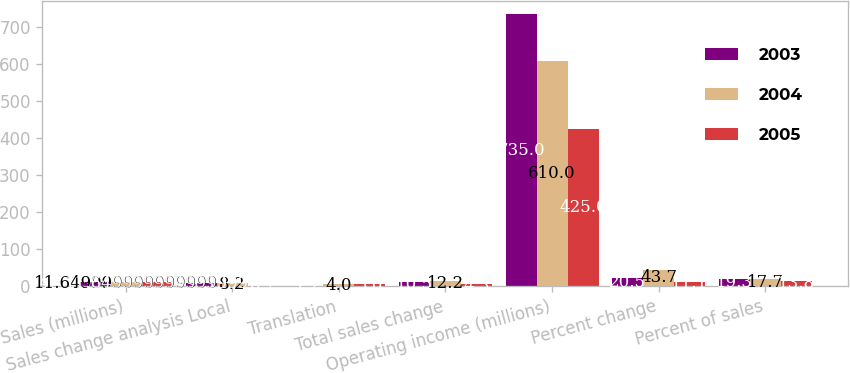Convert chart. <chart><loc_0><loc_0><loc_500><loc_500><stacked_bar_chart><ecel><fcel>Sales (millions)<fcel>Sales change analysis Local<fcel>Translation<fcel>Total sales change<fcel>Operating income (millions)<fcel>Percent change<fcel>Percent of sales<nl><fcel>2003<fcel>11.65<fcel>9.3<fcel>1.2<fcel>10.5<fcel>735<fcel>20.5<fcel>19.3<nl><fcel>2004<fcel>11.65<fcel>8.2<fcel>4<fcel>12.2<fcel>610<fcel>43.7<fcel>17.7<nl><fcel>2005<fcel>11.65<fcel>0.7<fcel>5<fcel>4.3<fcel>425<fcel>11.1<fcel>13.8<nl></chart> 